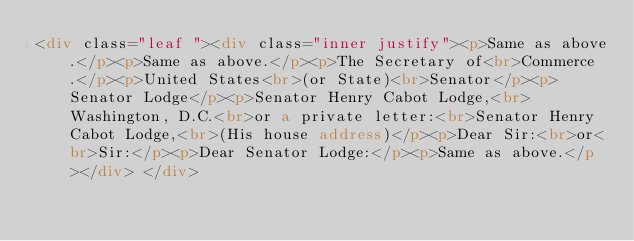Convert code to text. <code><loc_0><loc_0><loc_500><loc_500><_HTML_><div class="leaf "><div class="inner justify"><p>Same as above.</p><p>Same as above.</p><p>The Secretary of<br>Commerce.</p><p>United States<br>(or State)<br>Senator</p><p>Senator Lodge</p><p>Senator Henry Cabot Lodge,<br>Washington, D.C.<br>or a private letter:<br>Senator Henry Cabot Lodge,<br>(His house address)</p><p>Dear Sir:<br>or<br>Sir:</p><p>Dear Senator Lodge:</p><p>Same as above.</p></div> </div></code> 